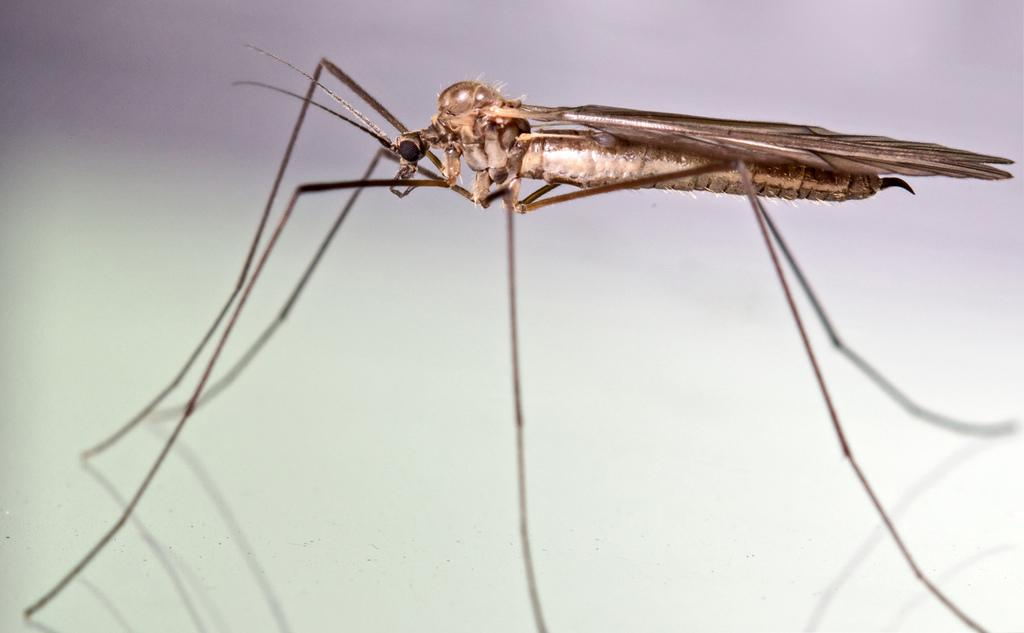What is the main subject of the image? The main subject of the image is a mosquito. Can you describe the surface on which the mosquito is located? The mosquito is on a white surface. How many trucks can be seen in the image? There are no trucks present in the image; it features a mosquito on a white surface. What type of whip is being used by the queen in the image? There is no queen or whip present in the image; it features a mosquito on a white surface. 